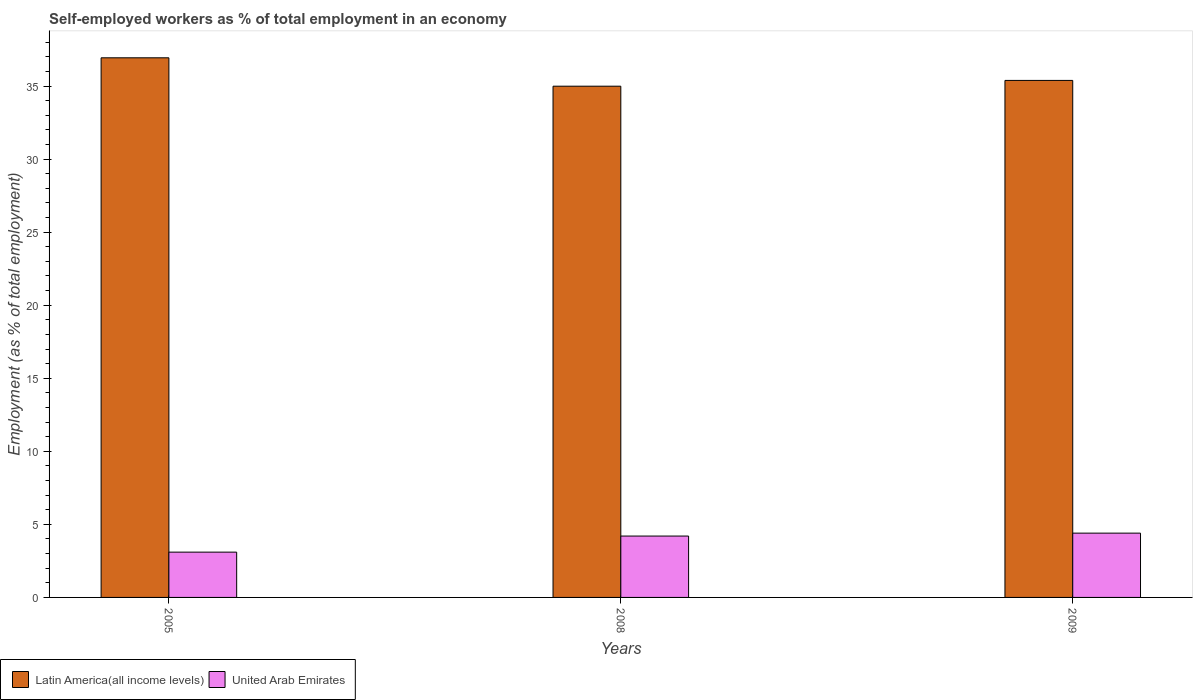How many different coloured bars are there?
Provide a short and direct response. 2. How many groups of bars are there?
Your answer should be compact. 3. Are the number of bars per tick equal to the number of legend labels?
Provide a short and direct response. Yes. Are the number of bars on each tick of the X-axis equal?
Offer a very short reply. Yes. How many bars are there on the 1st tick from the left?
Offer a very short reply. 2. In how many cases, is the number of bars for a given year not equal to the number of legend labels?
Offer a very short reply. 0. What is the percentage of self-employed workers in Latin America(all income levels) in 2009?
Keep it short and to the point. 35.39. Across all years, what is the maximum percentage of self-employed workers in Latin America(all income levels)?
Keep it short and to the point. 36.93. Across all years, what is the minimum percentage of self-employed workers in United Arab Emirates?
Offer a very short reply. 3.1. In which year was the percentage of self-employed workers in Latin America(all income levels) maximum?
Keep it short and to the point. 2005. In which year was the percentage of self-employed workers in United Arab Emirates minimum?
Your response must be concise. 2005. What is the total percentage of self-employed workers in United Arab Emirates in the graph?
Offer a terse response. 11.7. What is the difference between the percentage of self-employed workers in Latin America(all income levels) in 2008 and that in 2009?
Provide a short and direct response. -0.4. What is the difference between the percentage of self-employed workers in United Arab Emirates in 2005 and the percentage of self-employed workers in Latin America(all income levels) in 2009?
Your response must be concise. -32.29. What is the average percentage of self-employed workers in United Arab Emirates per year?
Offer a very short reply. 3.9. In the year 2008, what is the difference between the percentage of self-employed workers in Latin America(all income levels) and percentage of self-employed workers in United Arab Emirates?
Provide a succinct answer. 30.79. What is the ratio of the percentage of self-employed workers in Latin America(all income levels) in 2008 to that in 2009?
Your response must be concise. 0.99. Is the percentage of self-employed workers in United Arab Emirates in 2005 less than that in 2009?
Make the answer very short. Yes. What is the difference between the highest and the second highest percentage of self-employed workers in United Arab Emirates?
Your answer should be very brief. 0.2. What is the difference between the highest and the lowest percentage of self-employed workers in United Arab Emirates?
Make the answer very short. 1.3. What does the 2nd bar from the left in 2005 represents?
Your response must be concise. United Arab Emirates. What does the 2nd bar from the right in 2009 represents?
Keep it short and to the point. Latin America(all income levels). How many bars are there?
Your answer should be compact. 6. Are all the bars in the graph horizontal?
Your answer should be compact. No. How many years are there in the graph?
Your answer should be compact. 3. Does the graph contain any zero values?
Your answer should be very brief. No. Does the graph contain grids?
Your response must be concise. No. Where does the legend appear in the graph?
Give a very brief answer. Bottom left. How many legend labels are there?
Make the answer very short. 2. What is the title of the graph?
Give a very brief answer. Self-employed workers as % of total employment in an economy. What is the label or title of the X-axis?
Your answer should be very brief. Years. What is the label or title of the Y-axis?
Ensure brevity in your answer.  Employment (as % of total employment). What is the Employment (as % of total employment) in Latin America(all income levels) in 2005?
Provide a short and direct response. 36.93. What is the Employment (as % of total employment) of United Arab Emirates in 2005?
Make the answer very short. 3.1. What is the Employment (as % of total employment) in Latin America(all income levels) in 2008?
Offer a very short reply. 34.99. What is the Employment (as % of total employment) in United Arab Emirates in 2008?
Keep it short and to the point. 4.2. What is the Employment (as % of total employment) in Latin America(all income levels) in 2009?
Make the answer very short. 35.39. What is the Employment (as % of total employment) in United Arab Emirates in 2009?
Provide a succinct answer. 4.4. Across all years, what is the maximum Employment (as % of total employment) in Latin America(all income levels)?
Ensure brevity in your answer.  36.93. Across all years, what is the maximum Employment (as % of total employment) in United Arab Emirates?
Your answer should be compact. 4.4. Across all years, what is the minimum Employment (as % of total employment) of Latin America(all income levels)?
Your answer should be very brief. 34.99. Across all years, what is the minimum Employment (as % of total employment) in United Arab Emirates?
Make the answer very short. 3.1. What is the total Employment (as % of total employment) of Latin America(all income levels) in the graph?
Give a very brief answer. 107.31. What is the total Employment (as % of total employment) in United Arab Emirates in the graph?
Give a very brief answer. 11.7. What is the difference between the Employment (as % of total employment) of Latin America(all income levels) in 2005 and that in 2008?
Offer a very short reply. 1.94. What is the difference between the Employment (as % of total employment) of Latin America(all income levels) in 2005 and that in 2009?
Offer a terse response. 1.55. What is the difference between the Employment (as % of total employment) of United Arab Emirates in 2005 and that in 2009?
Your answer should be very brief. -1.3. What is the difference between the Employment (as % of total employment) of Latin America(all income levels) in 2008 and that in 2009?
Your answer should be compact. -0.4. What is the difference between the Employment (as % of total employment) in Latin America(all income levels) in 2005 and the Employment (as % of total employment) in United Arab Emirates in 2008?
Provide a succinct answer. 32.73. What is the difference between the Employment (as % of total employment) of Latin America(all income levels) in 2005 and the Employment (as % of total employment) of United Arab Emirates in 2009?
Give a very brief answer. 32.53. What is the difference between the Employment (as % of total employment) of Latin America(all income levels) in 2008 and the Employment (as % of total employment) of United Arab Emirates in 2009?
Provide a short and direct response. 30.59. What is the average Employment (as % of total employment) in Latin America(all income levels) per year?
Provide a succinct answer. 35.77. In the year 2005, what is the difference between the Employment (as % of total employment) in Latin America(all income levels) and Employment (as % of total employment) in United Arab Emirates?
Provide a short and direct response. 33.83. In the year 2008, what is the difference between the Employment (as % of total employment) in Latin America(all income levels) and Employment (as % of total employment) in United Arab Emirates?
Provide a succinct answer. 30.79. In the year 2009, what is the difference between the Employment (as % of total employment) of Latin America(all income levels) and Employment (as % of total employment) of United Arab Emirates?
Make the answer very short. 30.99. What is the ratio of the Employment (as % of total employment) in Latin America(all income levels) in 2005 to that in 2008?
Give a very brief answer. 1.06. What is the ratio of the Employment (as % of total employment) of United Arab Emirates in 2005 to that in 2008?
Ensure brevity in your answer.  0.74. What is the ratio of the Employment (as % of total employment) in Latin America(all income levels) in 2005 to that in 2009?
Provide a succinct answer. 1.04. What is the ratio of the Employment (as % of total employment) of United Arab Emirates in 2005 to that in 2009?
Offer a terse response. 0.7. What is the ratio of the Employment (as % of total employment) in Latin America(all income levels) in 2008 to that in 2009?
Your answer should be very brief. 0.99. What is the ratio of the Employment (as % of total employment) in United Arab Emirates in 2008 to that in 2009?
Offer a terse response. 0.95. What is the difference between the highest and the second highest Employment (as % of total employment) of Latin America(all income levels)?
Make the answer very short. 1.55. What is the difference between the highest and the lowest Employment (as % of total employment) of Latin America(all income levels)?
Offer a terse response. 1.94. 